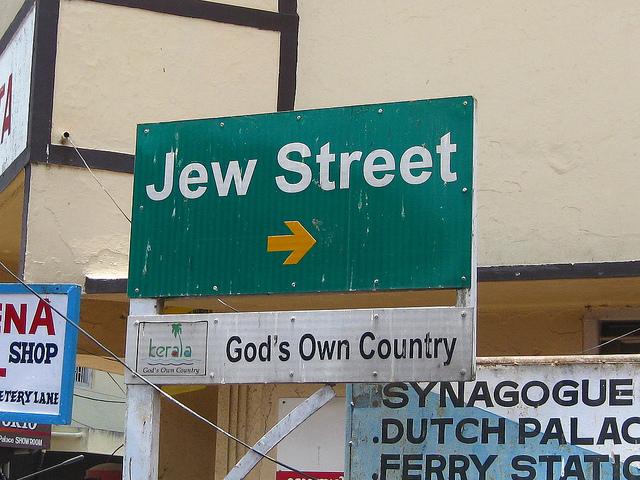What street is west?
Quick response, please. Jew street. What direction is Jew Street according to the sign?
Quick response, please. Right. Is there a sign for a place of worship?
Short answer required. Yes. Whose country is it?
Give a very brief answer. God's. Is this an Indian reservation?
Give a very brief answer. No. 